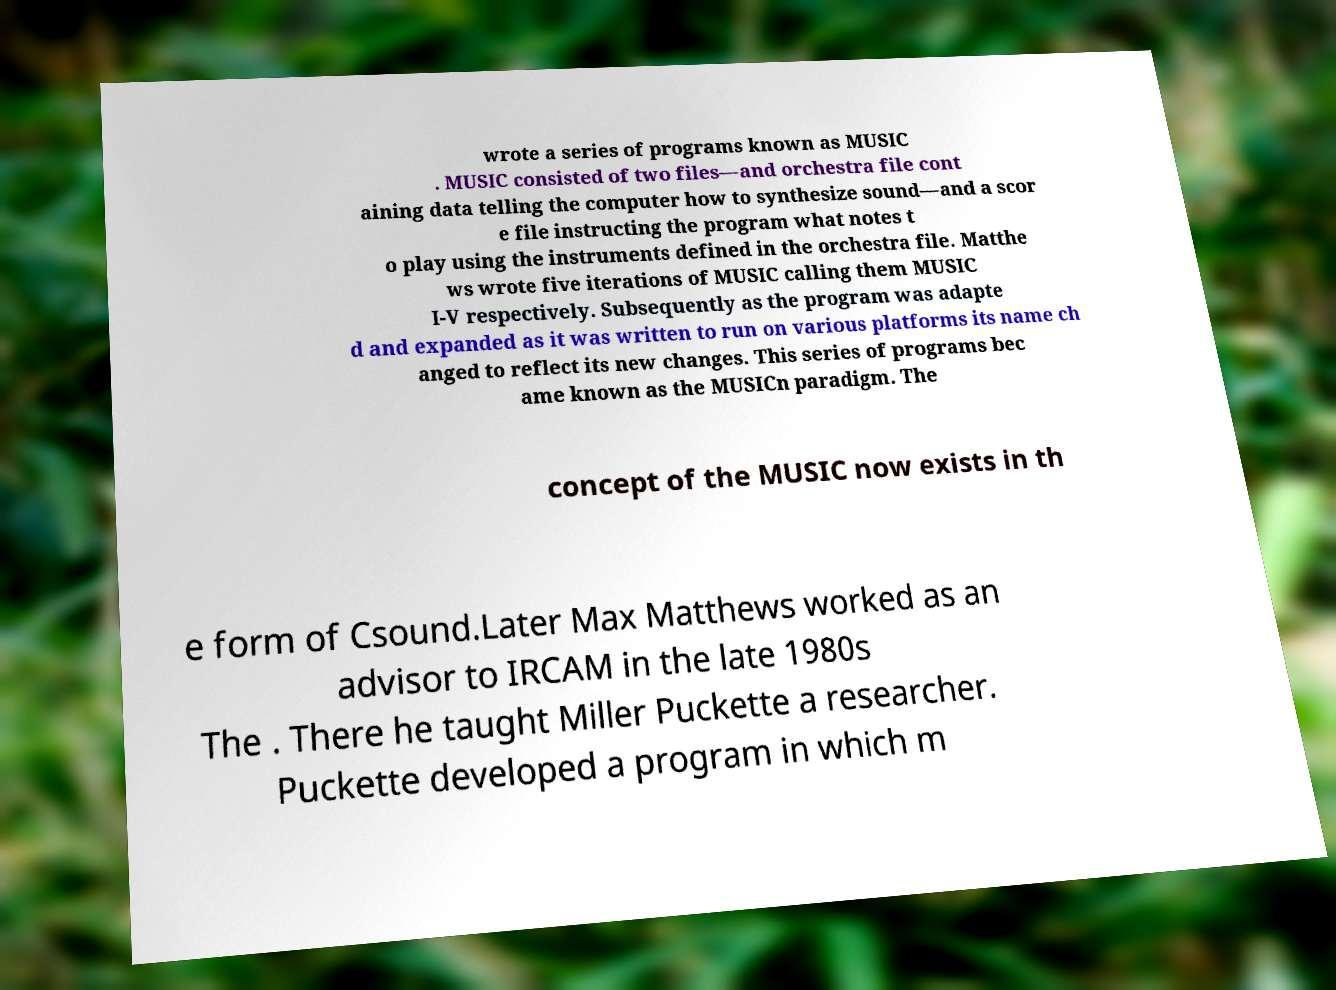Please read and relay the text visible in this image. What does it say? wrote a series of programs known as MUSIC . MUSIC consisted of two files—and orchestra file cont aining data telling the computer how to synthesize sound—and a scor e file instructing the program what notes t o play using the instruments defined in the orchestra file. Matthe ws wrote five iterations of MUSIC calling them MUSIC I-V respectively. Subsequently as the program was adapte d and expanded as it was written to run on various platforms its name ch anged to reflect its new changes. This series of programs bec ame known as the MUSICn paradigm. The concept of the MUSIC now exists in th e form of Csound.Later Max Matthews worked as an advisor to IRCAM in the late 1980s The . There he taught Miller Puckette a researcher. Puckette developed a program in which m 